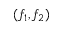<formula> <loc_0><loc_0><loc_500><loc_500>( f _ { 1 } , f _ { 2 } )</formula> 